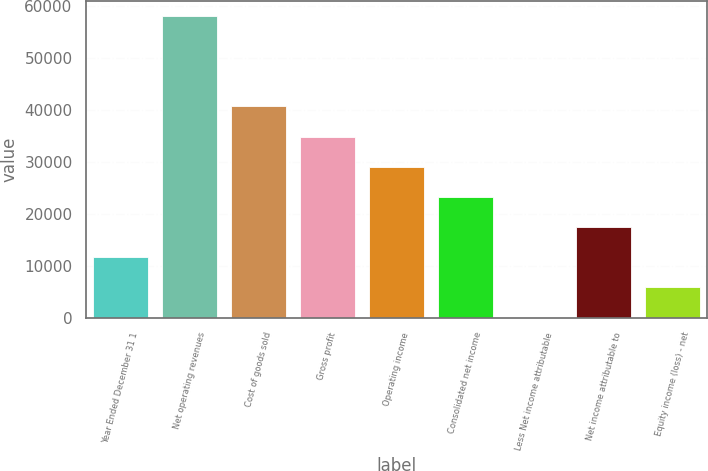Convert chart. <chart><loc_0><loc_0><loc_500><loc_500><bar_chart><fcel>Year Ended December 31 1<fcel>Net operating revenues<fcel>Cost of goods sold<fcel>Gross profit<fcel>Operating income<fcel>Consolidated net income<fcel>Less Net income attributable<fcel>Net income attributable to<fcel>Equity income (loss) - net<nl><fcel>11673.2<fcel>58054<fcel>40661.2<fcel>34863.6<fcel>29066<fcel>23268.4<fcel>78<fcel>17470.8<fcel>5875.6<nl></chart> 